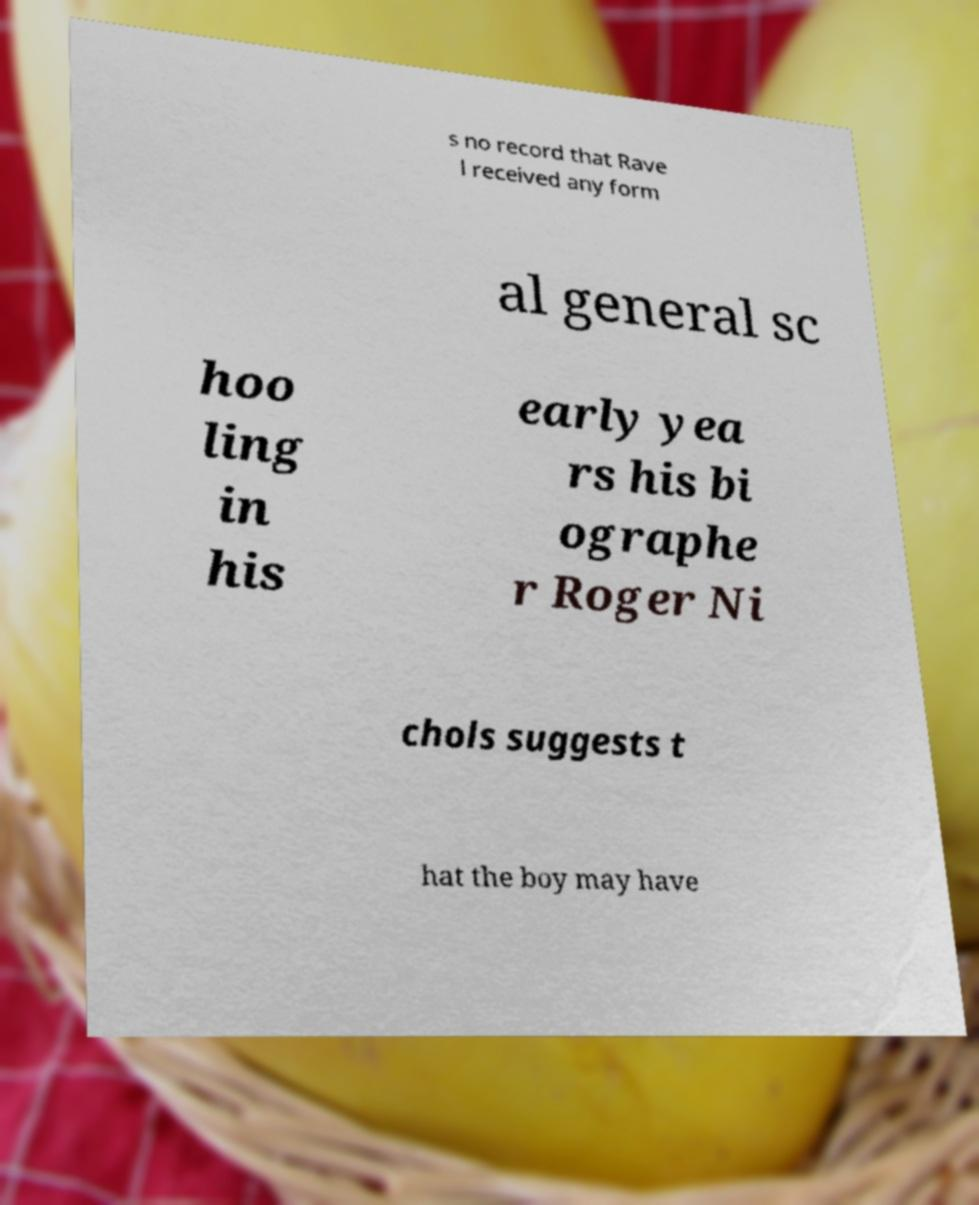Please identify and transcribe the text found in this image. s no record that Rave l received any form al general sc hoo ling in his early yea rs his bi ographe r Roger Ni chols suggests t hat the boy may have 